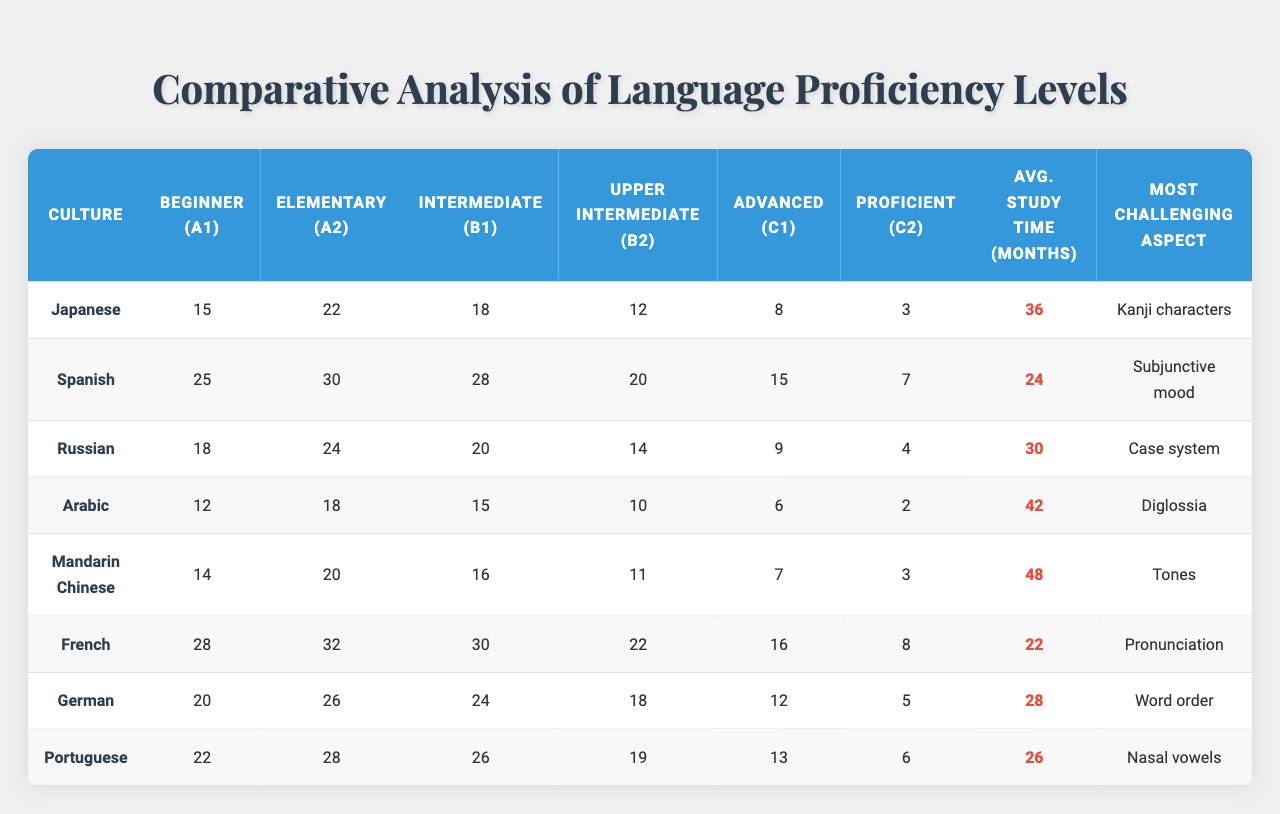What is the most challenging aspect of learning Japanese? According to the table, the most challenging aspect of learning Japanese is "Kanji characters." This is explicitly listed in the corresponding row for Japanese culture.
Answer: Kanji characters How many learners reach the Advanced (C1) level in Spanish? The table indicates that there are 15 learners who reach the Advanced (C1) level in Spanish, as found in the row dedicated to Spanish culture.
Answer: 15 Which culture has the highest number of learners at the Proficient (C2) level? Looking at the Proficient (C2) column, the Spanish culture has 7 learners, while others have either 3, 4, 2, 8, 5, or 6. Therefore, Spanish has the highest count at that level.
Answer: Spanish Calculate the average study time for mastering Japanese and Mandarin Chinese combined. The average study time for Japanese is 36 months and for Mandarin Chinese is 48 months. Summing these gives 36 + 48 = 84. There are 2 cultures involved, so the average is 84/2 = 42 months.
Answer: 42 months Is it true that more learners achieve the Upper Intermediate (B2) level in German than in Arabic? The table shows that there are 18 learners at the Upper Intermediate (B2) level for German and only 10 for Arabic. Since 18 is more than 10, the statement is true.
Answer: Yes How do the numbers of learners at the Elementary (A2) level compare between French and Russian? For French, there are 32 learners at the Elementary (A2) level, whereas for Russian there are 24. Since 32 is greater than 24, French has more learners at that level.
Answer: French has more learners What is the difference in total learners between the Beginner (A1) level for Spanish and Japanese? Spanish has 25 learners at the Beginner (A1) level while Japanese has 15. The difference is calculated as 25 - 15 = 10 learners.
Answer: 10 learners Which culture has the lowest average study time and what is that time? By comparing the average study times listed in the table, Arabic shows the lowest with 42 months.
Answer: Arabic, 42 months List the proficiency level with the highest number of learners for Portuguese. In the case of Portuguese, the highest number of learners is at the Intermediate (B1) level, where there are 26 learners. This is evident from analyzing the row for Portuguese.
Answer: Intermediate (B1) What proficiency level shows the greatest decline in learners from the Beginner (A1) level for Japanese to the Proficient (C2) level? For Japanese, the decline from Beginner (A1) to Proficient (C2) is from 15 learners to 3 learners. This is a decrease of 12, indicating a significant drop in learners at the higher proficiency level.
Answer: 12 learners decline 